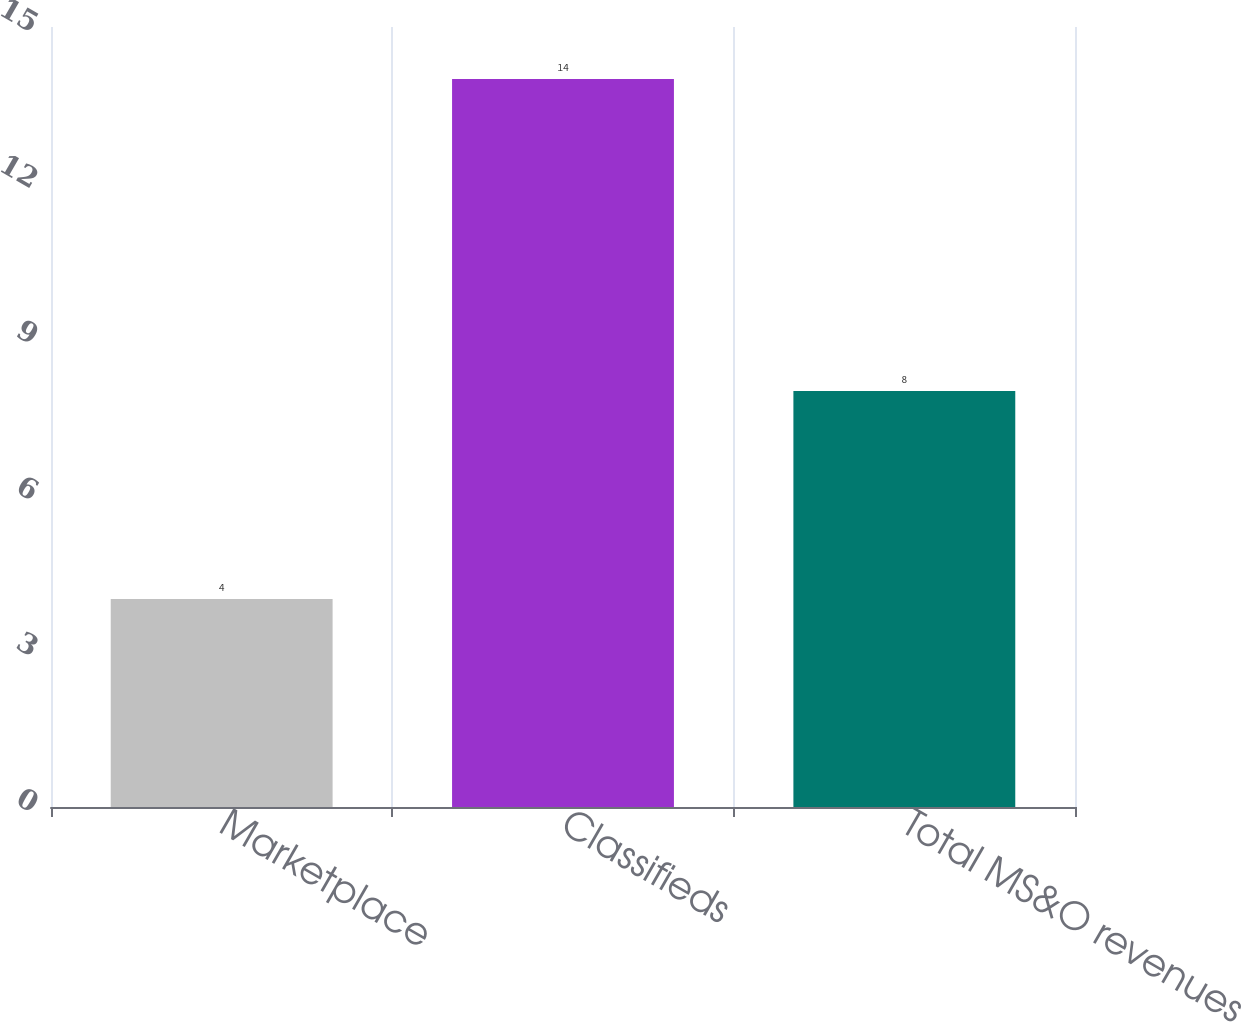<chart> <loc_0><loc_0><loc_500><loc_500><bar_chart><fcel>Marketplace<fcel>Classifieds<fcel>Total MS&O revenues<nl><fcel>4<fcel>14<fcel>8<nl></chart> 